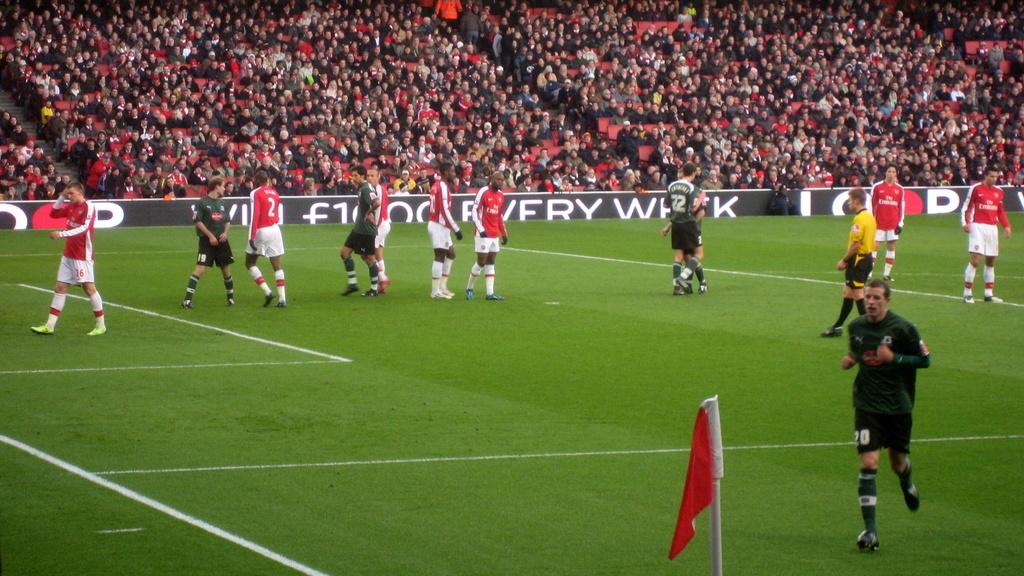<image>
Relay a brief, clear account of the picture shown. Player number 2 on the team with the red shirts has his back turned. 